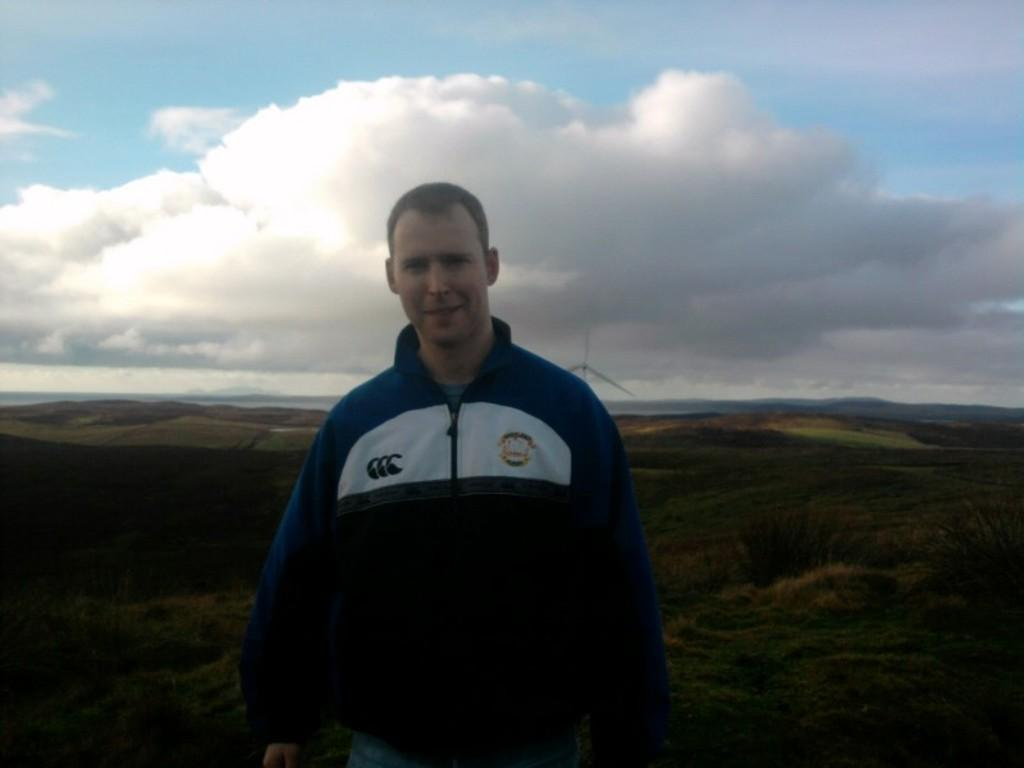Who is present in the image? There is a person in the image. What is the person doing in the image? The person is watching and smiling. What can be seen in the background of the image? There are plants, grass, hills, a windmill, and a cloudy sky in the background of the image. What type of produce is the woman harvesting in the image? There is no woman present in the image, and no produce is being harvested. 